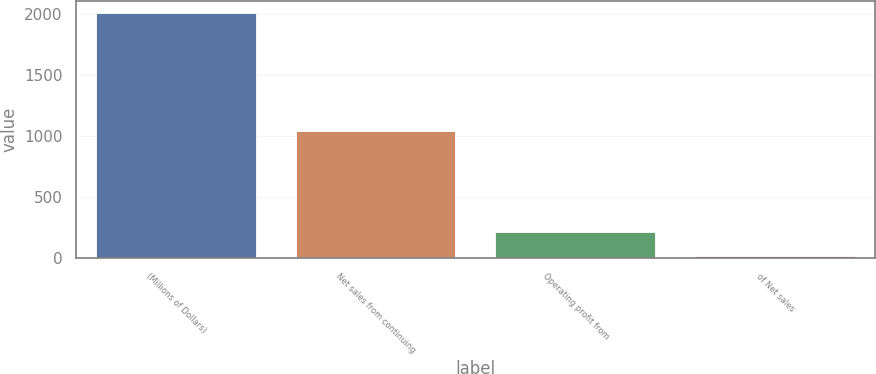<chart> <loc_0><loc_0><loc_500><loc_500><bar_chart><fcel>(Millions of Dollars)<fcel>Net sales from continuing<fcel>Operating profit from<fcel>of Net sales<nl><fcel>2004<fcel>1043<fcel>215.16<fcel>16.4<nl></chart> 